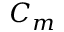<formula> <loc_0><loc_0><loc_500><loc_500>C _ { m }</formula> 